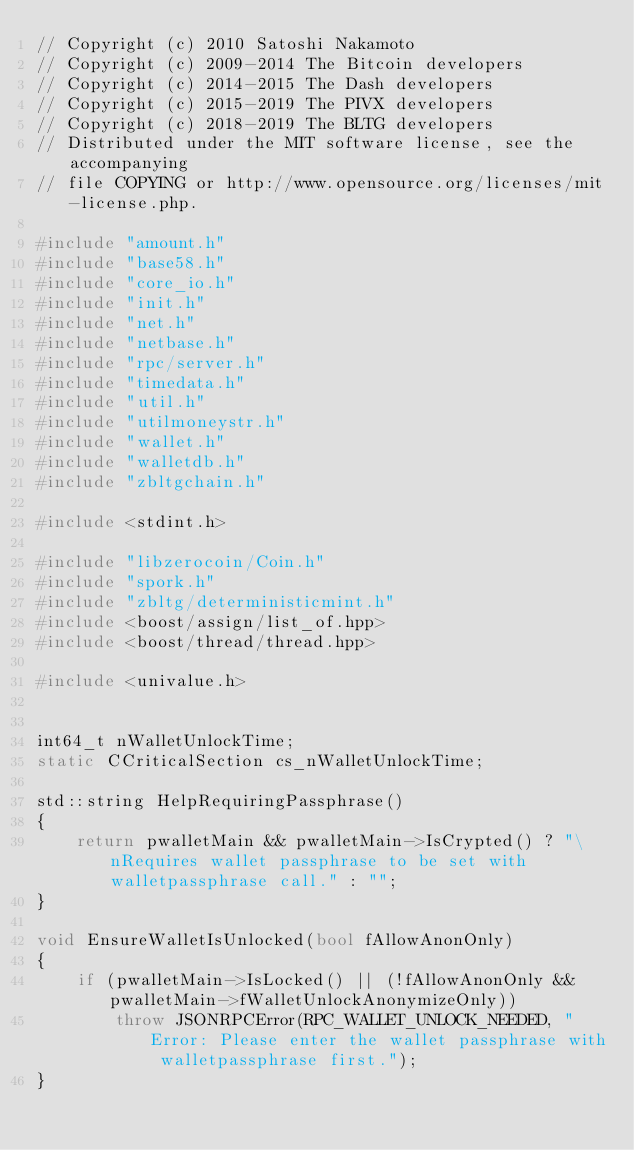Convert code to text. <code><loc_0><loc_0><loc_500><loc_500><_C++_>// Copyright (c) 2010 Satoshi Nakamoto
// Copyright (c) 2009-2014 The Bitcoin developers
// Copyright (c) 2014-2015 The Dash developers
// Copyright (c) 2015-2019 The PIVX developers
// Copyright (c) 2018-2019 The BLTG developers
// Distributed under the MIT software license, see the accompanying
// file COPYING or http://www.opensource.org/licenses/mit-license.php.

#include "amount.h"
#include "base58.h"
#include "core_io.h"
#include "init.h"
#include "net.h"
#include "netbase.h"
#include "rpc/server.h"
#include "timedata.h"
#include "util.h"
#include "utilmoneystr.h"
#include "wallet.h"
#include "walletdb.h"
#include "zbltgchain.h"

#include <stdint.h>

#include "libzerocoin/Coin.h"
#include "spork.h"
#include "zbltg/deterministicmint.h"
#include <boost/assign/list_of.hpp>
#include <boost/thread/thread.hpp>

#include <univalue.h>


int64_t nWalletUnlockTime;
static CCriticalSection cs_nWalletUnlockTime;

std::string HelpRequiringPassphrase()
{
    return pwalletMain && pwalletMain->IsCrypted() ? "\nRequires wallet passphrase to be set with walletpassphrase call." : "";
}

void EnsureWalletIsUnlocked(bool fAllowAnonOnly)
{
    if (pwalletMain->IsLocked() || (!fAllowAnonOnly && pwalletMain->fWalletUnlockAnonymizeOnly))
        throw JSONRPCError(RPC_WALLET_UNLOCK_NEEDED, "Error: Please enter the wallet passphrase with walletpassphrase first.");
}
</code> 